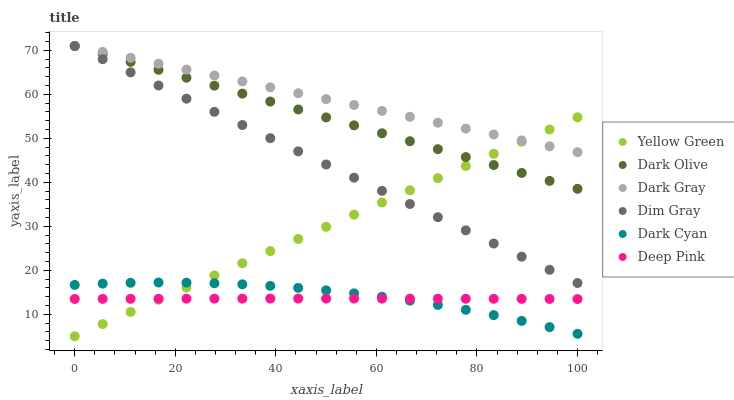Does Deep Pink have the minimum area under the curve?
Answer yes or no. Yes. Does Dark Gray have the maximum area under the curve?
Answer yes or no. Yes. Does Yellow Green have the minimum area under the curve?
Answer yes or no. No. Does Yellow Green have the maximum area under the curve?
Answer yes or no. No. Is Yellow Green the smoothest?
Answer yes or no. Yes. Is Dark Cyan the roughest?
Answer yes or no. Yes. Is Dark Olive the smoothest?
Answer yes or no. No. Is Dark Olive the roughest?
Answer yes or no. No. Does Yellow Green have the lowest value?
Answer yes or no. Yes. Does Dark Olive have the lowest value?
Answer yes or no. No. Does Dark Gray have the highest value?
Answer yes or no. Yes. Does Yellow Green have the highest value?
Answer yes or no. No. Is Deep Pink less than Dim Gray?
Answer yes or no. Yes. Is Dim Gray greater than Dark Cyan?
Answer yes or no. Yes. Does Yellow Green intersect Dim Gray?
Answer yes or no. Yes. Is Yellow Green less than Dim Gray?
Answer yes or no. No. Is Yellow Green greater than Dim Gray?
Answer yes or no. No. Does Deep Pink intersect Dim Gray?
Answer yes or no. No. 